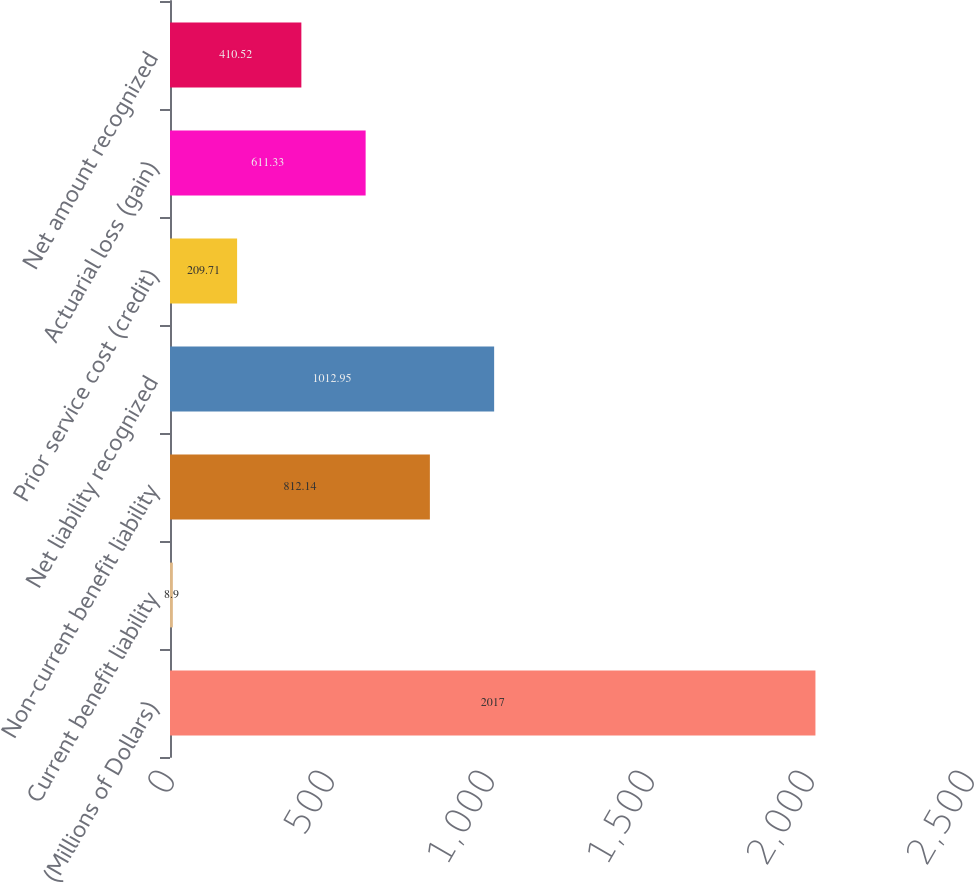Convert chart. <chart><loc_0><loc_0><loc_500><loc_500><bar_chart><fcel>(Millions of Dollars)<fcel>Current benefit liability<fcel>Non-current benefit liability<fcel>Net liability recognized<fcel>Prior service cost (credit)<fcel>Actuarial loss (gain)<fcel>Net amount recognized<nl><fcel>2017<fcel>8.9<fcel>812.14<fcel>1012.95<fcel>209.71<fcel>611.33<fcel>410.52<nl></chart> 